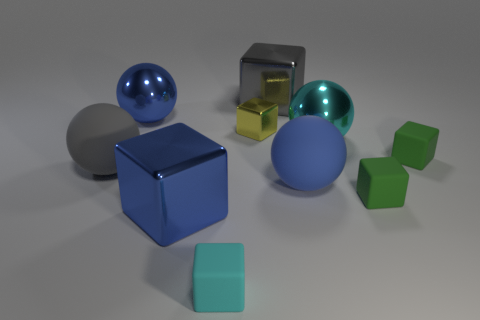Subtract all large gray matte spheres. How many spheres are left? 3 Subtract 5 blocks. How many blocks are left? 1 Subtract all cyan cubes. How many cubes are left? 5 Subtract all blue blocks. Subtract all red balls. How many blocks are left? 5 Subtract all green balls. How many green cubes are left? 2 Subtract 0 red cubes. How many objects are left? 10 Subtract all blocks. How many objects are left? 4 Subtract all cylinders. Subtract all tiny metal objects. How many objects are left? 9 Add 2 big blocks. How many big blocks are left? 4 Add 4 red cylinders. How many red cylinders exist? 4 